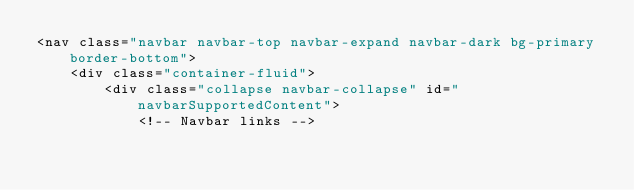<code> <loc_0><loc_0><loc_500><loc_500><_PHP_><nav class="navbar navbar-top navbar-expand navbar-dark bg-primary border-bottom">
    <div class="container-fluid">
        <div class="collapse navbar-collapse" id="navbarSupportedContent">
            <!-- Navbar links --></code> 